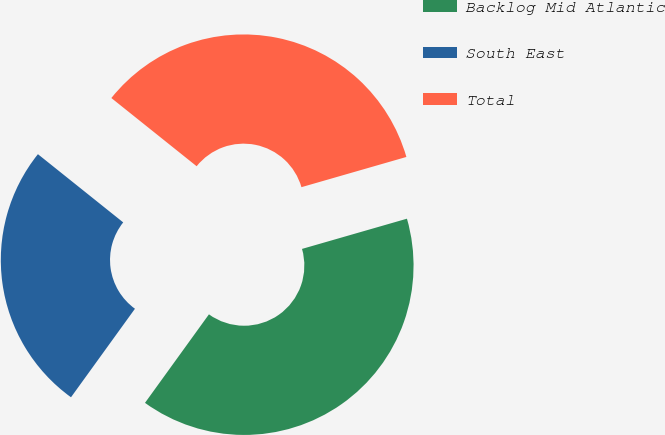<chart> <loc_0><loc_0><loc_500><loc_500><pie_chart><fcel>Backlog Mid Atlantic<fcel>South East<fcel>Total<nl><fcel>39.42%<fcel>25.78%<fcel>34.8%<nl></chart> 